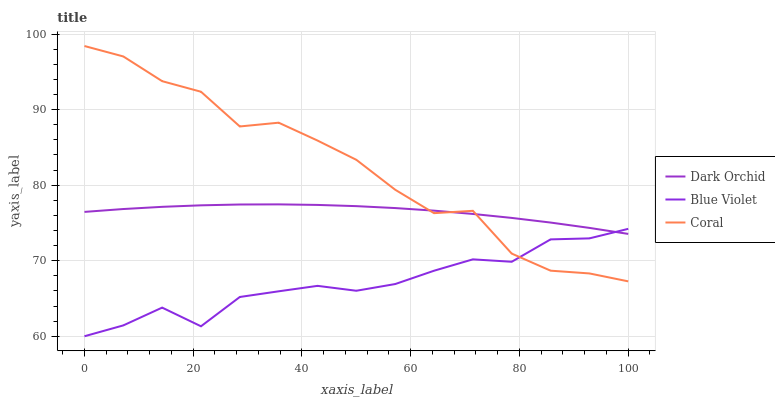Does Blue Violet have the minimum area under the curve?
Answer yes or no. Yes. Does Coral have the maximum area under the curve?
Answer yes or no. Yes. Does Dark Orchid have the minimum area under the curve?
Answer yes or no. No. Does Dark Orchid have the maximum area under the curve?
Answer yes or no. No. Is Dark Orchid the smoothest?
Answer yes or no. Yes. Is Coral the roughest?
Answer yes or no. Yes. Is Blue Violet the smoothest?
Answer yes or no. No. Is Blue Violet the roughest?
Answer yes or no. No. Does Blue Violet have the lowest value?
Answer yes or no. Yes. Does Dark Orchid have the lowest value?
Answer yes or no. No. Does Coral have the highest value?
Answer yes or no. Yes. Does Dark Orchid have the highest value?
Answer yes or no. No. Does Dark Orchid intersect Blue Violet?
Answer yes or no. Yes. Is Dark Orchid less than Blue Violet?
Answer yes or no. No. Is Dark Orchid greater than Blue Violet?
Answer yes or no. No. 